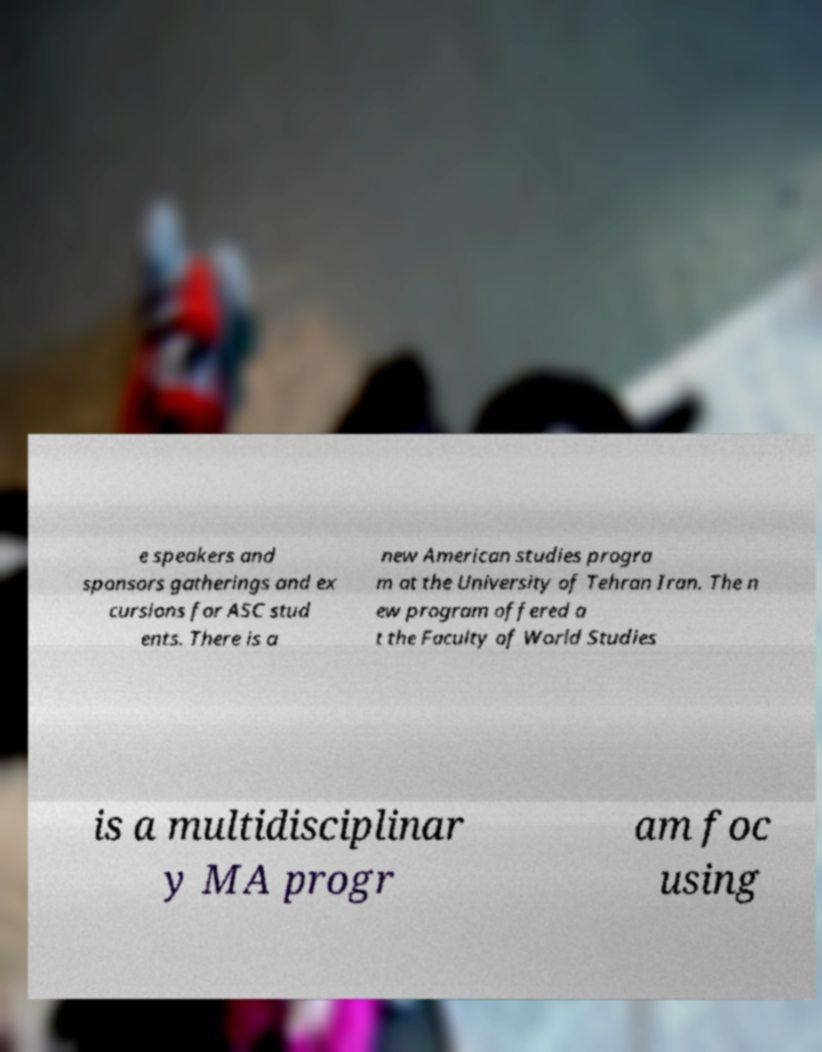Please read and relay the text visible in this image. What does it say? e speakers and sponsors gatherings and ex cursions for ASC stud ents. There is a new American studies progra m at the University of Tehran Iran. The n ew program offered a t the Faculty of World Studies is a multidisciplinar y MA progr am foc using 